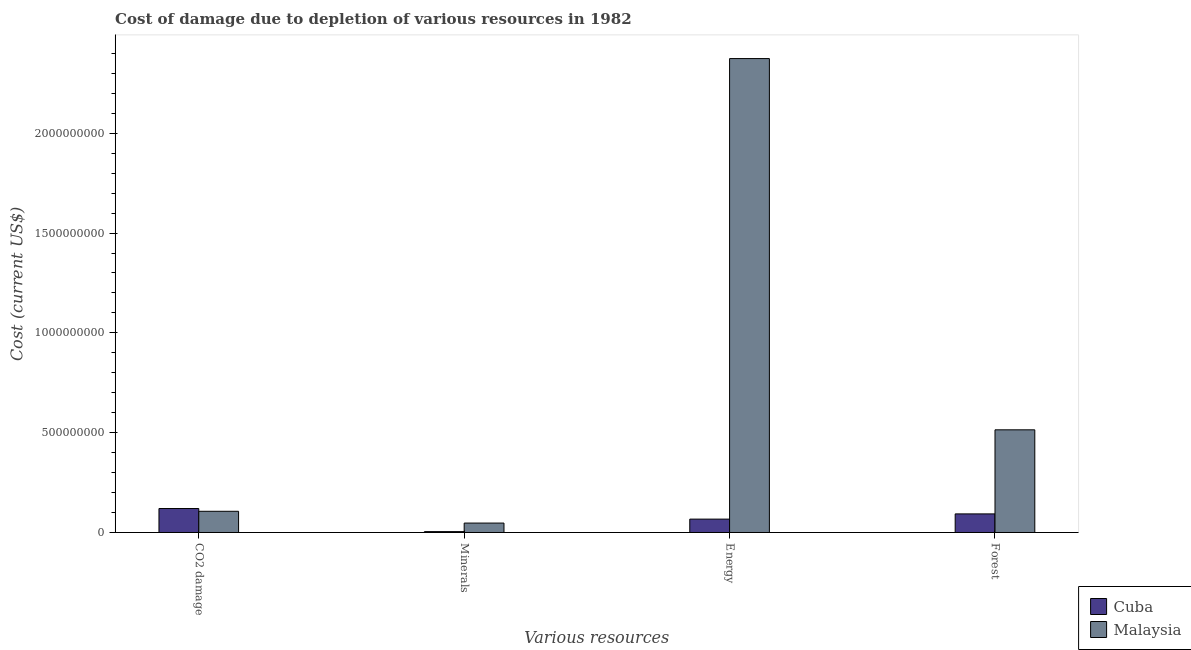How many different coloured bars are there?
Offer a very short reply. 2. Are the number of bars on each tick of the X-axis equal?
Provide a short and direct response. Yes. How many bars are there on the 4th tick from the left?
Offer a terse response. 2. What is the label of the 3rd group of bars from the left?
Your answer should be very brief. Energy. What is the cost of damage due to depletion of minerals in Cuba?
Your answer should be compact. 4.38e+06. Across all countries, what is the maximum cost of damage due to depletion of energy?
Your response must be concise. 2.37e+09. Across all countries, what is the minimum cost of damage due to depletion of forests?
Offer a very short reply. 9.31e+07. In which country was the cost of damage due to depletion of minerals maximum?
Offer a terse response. Malaysia. In which country was the cost of damage due to depletion of minerals minimum?
Provide a short and direct response. Cuba. What is the total cost of damage due to depletion of coal in the graph?
Make the answer very short. 2.26e+08. What is the difference between the cost of damage due to depletion of forests in Malaysia and that in Cuba?
Ensure brevity in your answer.  4.21e+08. What is the difference between the cost of damage due to depletion of minerals in Malaysia and the cost of damage due to depletion of forests in Cuba?
Give a very brief answer. -4.60e+07. What is the average cost of damage due to depletion of minerals per country?
Your answer should be compact. 2.58e+07. What is the difference between the cost of damage due to depletion of minerals and cost of damage due to depletion of energy in Malaysia?
Make the answer very short. -2.33e+09. In how many countries, is the cost of damage due to depletion of energy greater than 1600000000 US$?
Make the answer very short. 1. What is the ratio of the cost of damage due to depletion of forests in Malaysia to that in Cuba?
Your answer should be very brief. 5.52. Is the difference between the cost of damage due to depletion of coal in Malaysia and Cuba greater than the difference between the cost of damage due to depletion of energy in Malaysia and Cuba?
Keep it short and to the point. No. What is the difference between the highest and the second highest cost of damage due to depletion of forests?
Your response must be concise. 4.21e+08. What is the difference between the highest and the lowest cost of damage due to depletion of coal?
Your answer should be very brief. 1.38e+07. In how many countries, is the cost of damage due to depletion of minerals greater than the average cost of damage due to depletion of minerals taken over all countries?
Your answer should be compact. 1. Is it the case that in every country, the sum of the cost of damage due to depletion of minerals and cost of damage due to depletion of coal is greater than the sum of cost of damage due to depletion of forests and cost of damage due to depletion of energy?
Keep it short and to the point. No. What does the 1st bar from the left in CO2 damage represents?
Make the answer very short. Cuba. What does the 2nd bar from the right in Forest represents?
Your response must be concise. Cuba. Is it the case that in every country, the sum of the cost of damage due to depletion of coal and cost of damage due to depletion of minerals is greater than the cost of damage due to depletion of energy?
Give a very brief answer. No. How many bars are there?
Provide a short and direct response. 8. Are all the bars in the graph horizontal?
Your answer should be compact. No. How many countries are there in the graph?
Make the answer very short. 2. Are the values on the major ticks of Y-axis written in scientific E-notation?
Make the answer very short. No. Does the graph contain any zero values?
Provide a succinct answer. No. Where does the legend appear in the graph?
Keep it short and to the point. Bottom right. How many legend labels are there?
Offer a terse response. 2. How are the legend labels stacked?
Your answer should be compact. Vertical. What is the title of the graph?
Your answer should be very brief. Cost of damage due to depletion of various resources in 1982 . What is the label or title of the X-axis?
Your answer should be very brief. Various resources. What is the label or title of the Y-axis?
Make the answer very short. Cost (current US$). What is the Cost (current US$) of Cuba in CO2 damage?
Your answer should be very brief. 1.20e+08. What is the Cost (current US$) in Malaysia in CO2 damage?
Your answer should be compact. 1.06e+08. What is the Cost (current US$) of Cuba in Minerals?
Give a very brief answer. 4.38e+06. What is the Cost (current US$) of Malaysia in Minerals?
Provide a short and direct response. 4.71e+07. What is the Cost (current US$) in Cuba in Energy?
Ensure brevity in your answer.  6.70e+07. What is the Cost (current US$) of Malaysia in Energy?
Your answer should be very brief. 2.37e+09. What is the Cost (current US$) in Cuba in Forest?
Give a very brief answer. 9.31e+07. What is the Cost (current US$) of Malaysia in Forest?
Give a very brief answer. 5.14e+08. Across all Various resources, what is the maximum Cost (current US$) in Cuba?
Offer a terse response. 1.20e+08. Across all Various resources, what is the maximum Cost (current US$) in Malaysia?
Keep it short and to the point. 2.37e+09. Across all Various resources, what is the minimum Cost (current US$) of Cuba?
Give a very brief answer. 4.38e+06. Across all Various resources, what is the minimum Cost (current US$) of Malaysia?
Make the answer very short. 4.71e+07. What is the total Cost (current US$) in Cuba in the graph?
Offer a very short reply. 2.85e+08. What is the total Cost (current US$) of Malaysia in the graph?
Offer a terse response. 3.04e+09. What is the difference between the Cost (current US$) in Cuba in CO2 damage and that in Minerals?
Provide a short and direct response. 1.16e+08. What is the difference between the Cost (current US$) in Malaysia in CO2 damage and that in Minerals?
Offer a very short reply. 5.90e+07. What is the difference between the Cost (current US$) in Cuba in CO2 damage and that in Energy?
Your answer should be compact. 5.30e+07. What is the difference between the Cost (current US$) in Malaysia in CO2 damage and that in Energy?
Make the answer very short. -2.27e+09. What is the difference between the Cost (current US$) of Cuba in CO2 damage and that in Forest?
Provide a short and direct response. 2.69e+07. What is the difference between the Cost (current US$) of Malaysia in CO2 damage and that in Forest?
Give a very brief answer. -4.08e+08. What is the difference between the Cost (current US$) in Cuba in Minerals and that in Energy?
Your response must be concise. -6.26e+07. What is the difference between the Cost (current US$) of Malaysia in Minerals and that in Energy?
Ensure brevity in your answer.  -2.33e+09. What is the difference between the Cost (current US$) of Cuba in Minerals and that in Forest?
Ensure brevity in your answer.  -8.88e+07. What is the difference between the Cost (current US$) in Malaysia in Minerals and that in Forest?
Offer a terse response. -4.67e+08. What is the difference between the Cost (current US$) in Cuba in Energy and that in Forest?
Make the answer very short. -2.62e+07. What is the difference between the Cost (current US$) of Malaysia in Energy and that in Forest?
Make the answer very short. 1.86e+09. What is the difference between the Cost (current US$) in Cuba in CO2 damage and the Cost (current US$) in Malaysia in Minerals?
Your answer should be very brief. 7.29e+07. What is the difference between the Cost (current US$) in Cuba in CO2 damage and the Cost (current US$) in Malaysia in Energy?
Give a very brief answer. -2.25e+09. What is the difference between the Cost (current US$) of Cuba in CO2 damage and the Cost (current US$) of Malaysia in Forest?
Keep it short and to the point. -3.94e+08. What is the difference between the Cost (current US$) of Cuba in Minerals and the Cost (current US$) of Malaysia in Energy?
Offer a very short reply. -2.37e+09. What is the difference between the Cost (current US$) in Cuba in Minerals and the Cost (current US$) in Malaysia in Forest?
Offer a terse response. -5.10e+08. What is the difference between the Cost (current US$) of Cuba in Energy and the Cost (current US$) of Malaysia in Forest?
Make the answer very short. -4.47e+08. What is the average Cost (current US$) of Cuba per Various resources?
Offer a very short reply. 7.11e+07. What is the average Cost (current US$) of Malaysia per Various resources?
Offer a very short reply. 7.60e+08. What is the difference between the Cost (current US$) of Cuba and Cost (current US$) of Malaysia in CO2 damage?
Make the answer very short. 1.38e+07. What is the difference between the Cost (current US$) in Cuba and Cost (current US$) in Malaysia in Minerals?
Ensure brevity in your answer.  -4.28e+07. What is the difference between the Cost (current US$) in Cuba and Cost (current US$) in Malaysia in Energy?
Provide a short and direct response. -2.31e+09. What is the difference between the Cost (current US$) of Cuba and Cost (current US$) of Malaysia in Forest?
Provide a short and direct response. -4.21e+08. What is the ratio of the Cost (current US$) in Cuba in CO2 damage to that in Minerals?
Your answer should be very brief. 27.4. What is the ratio of the Cost (current US$) of Malaysia in CO2 damage to that in Minerals?
Ensure brevity in your answer.  2.25. What is the ratio of the Cost (current US$) of Cuba in CO2 damage to that in Energy?
Your answer should be compact. 1.79. What is the ratio of the Cost (current US$) in Malaysia in CO2 damage to that in Energy?
Provide a short and direct response. 0.04. What is the ratio of the Cost (current US$) in Cuba in CO2 damage to that in Forest?
Make the answer very short. 1.29. What is the ratio of the Cost (current US$) of Malaysia in CO2 damage to that in Forest?
Ensure brevity in your answer.  0.21. What is the ratio of the Cost (current US$) of Cuba in Minerals to that in Energy?
Offer a terse response. 0.07. What is the ratio of the Cost (current US$) in Malaysia in Minerals to that in Energy?
Offer a terse response. 0.02. What is the ratio of the Cost (current US$) of Cuba in Minerals to that in Forest?
Make the answer very short. 0.05. What is the ratio of the Cost (current US$) of Malaysia in Minerals to that in Forest?
Your answer should be very brief. 0.09. What is the ratio of the Cost (current US$) in Cuba in Energy to that in Forest?
Your response must be concise. 0.72. What is the ratio of the Cost (current US$) of Malaysia in Energy to that in Forest?
Keep it short and to the point. 4.62. What is the difference between the highest and the second highest Cost (current US$) in Cuba?
Offer a very short reply. 2.69e+07. What is the difference between the highest and the second highest Cost (current US$) in Malaysia?
Your response must be concise. 1.86e+09. What is the difference between the highest and the lowest Cost (current US$) in Cuba?
Provide a succinct answer. 1.16e+08. What is the difference between the highest and the lowest Cost (current US$) in Malaysia?
Offer a terse response. 2.33e+09. 